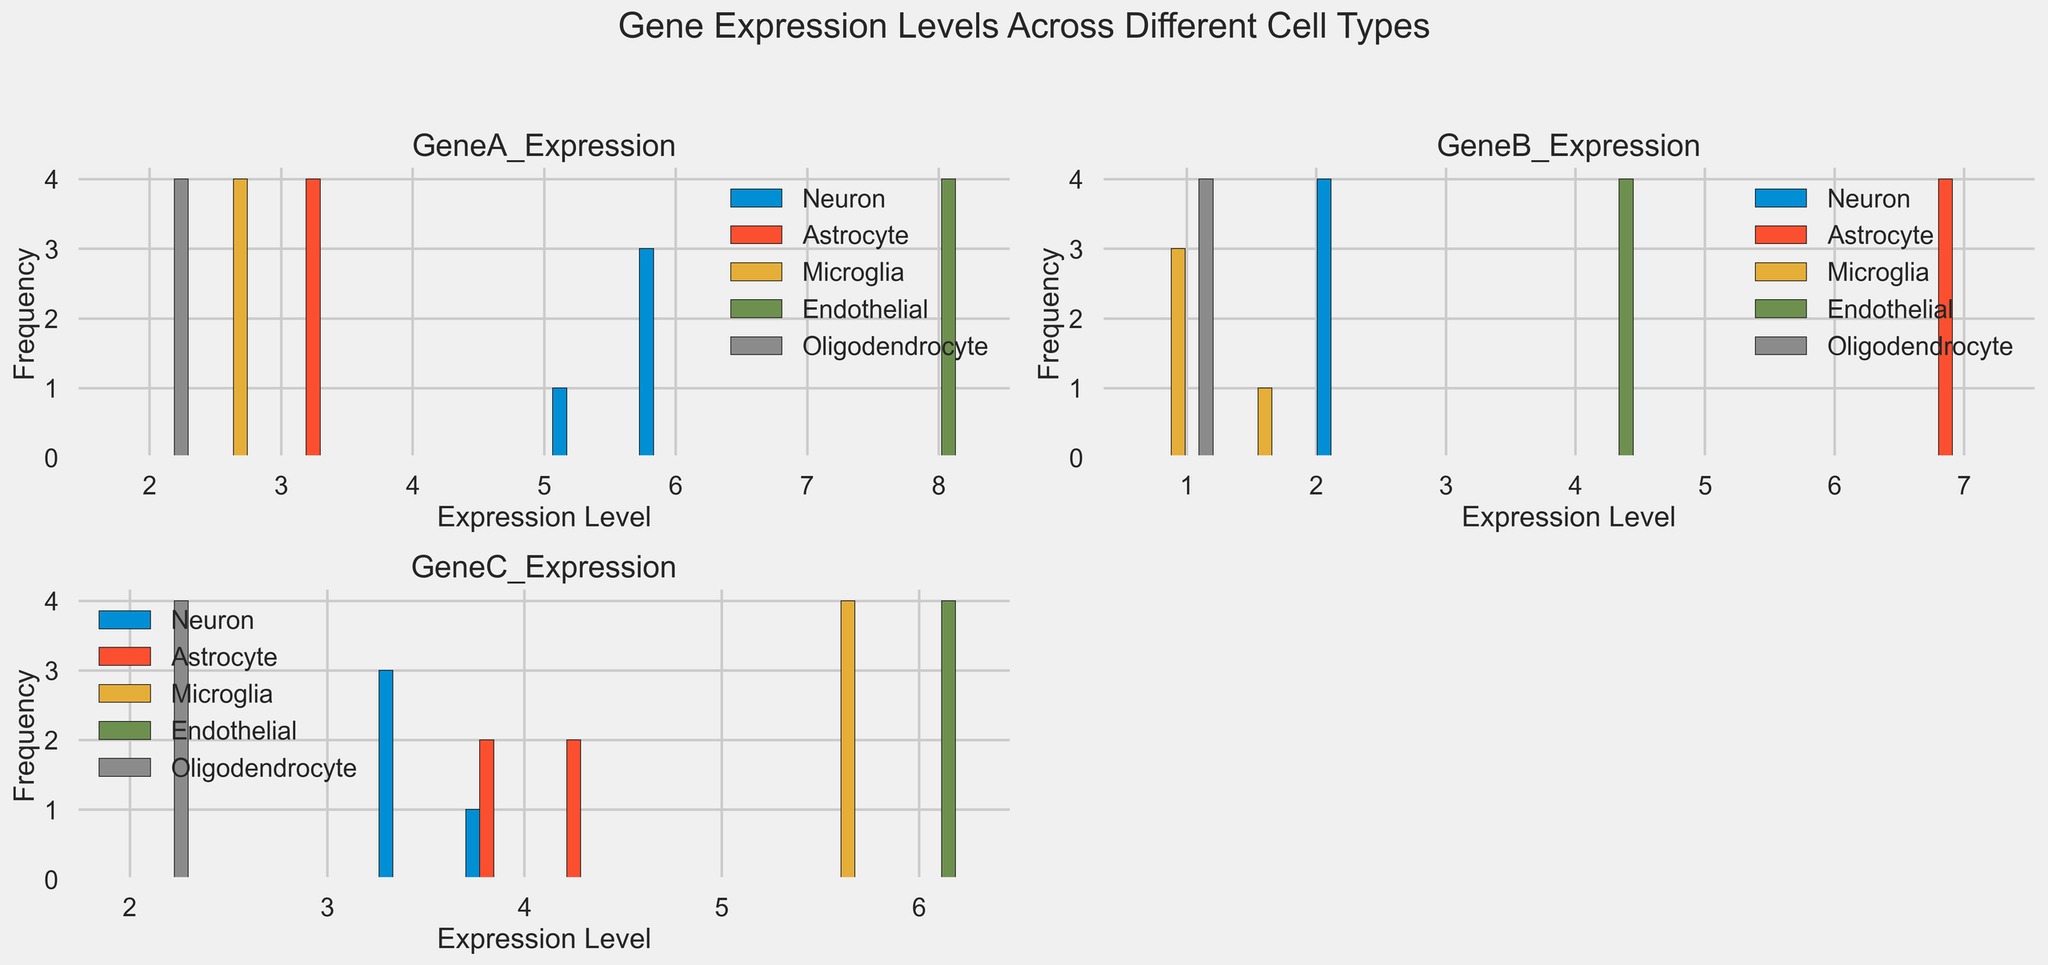Which cell type has the highest average expression level of GeneA? By looking at the histograms for GeneA expression, Endothelial cells show the highest average expression level because their bars are concentrated at higher expression values compared to the other cell types.
Answer: Endothelial Which gene has the most uniform expression levels across all cell types? By examining the histograms, GeneC shows relatively uniform distribution across all cell types, as the bars are more evenly distributed across the range. GeneA and GeneB show more variation in distribution shapes.
Answer: GeneC Which cell type has the lowest variability in GeneB expression levels? Observing the histograms for GeneB expression, Oligodendrocytes show very low variability, as their bars are concentrated around a narrow range of expression levels.
Answer: Oligodendrocyte Which gene has the largest range of expression levels within any single cell type? Checking each gene's histograms, GeneB in Astrocytes demonstrates the largest range of expression levels, with bars spread widely across the range.
Answer: GeneB How does GeneC expression in Microglia compare to that in Neurons? In the histograms for GeneC, Microglia show higher expression levels with bars centered around higher values compared to Neurons.
Answer: Microglia Which cell type shows the highest peak in the histogram for GeneA expression? For GeneA expression, Endothelial cells have the highest peak, indicating a large number of cells within a narrow high-expression range.
Answer: Endothelial What is the approximate average expression level of GeneC in Oligodendrocytes? For GeneC expression in Oligodendrocytes, the bars are concentrated around 2.0, suggesting the average is approximately around this value.
Answer: ~2.0 Which cell type has the most distinct expression pattern for GeneB? Looking at GeneB histograms, Astrocytes have a distinct pattern with high expression levels, which is very different from the other cell types' patterns.
Answer: Astrocyte Among all the cell types, which one has the widest spread of expression levels for GeneA? Neurons show the widest spread in GeneA expression as their histogram bars cover a broader range of expression levels compared to other cell types.
Answer: Neuron For GeneC, which cell type has the second highest expression level after Endothelial cells? For GeneC expression, after Endothelial cells, Microglia have the second-highest expression levels based on the histogram bars.
Answer: Microglia 